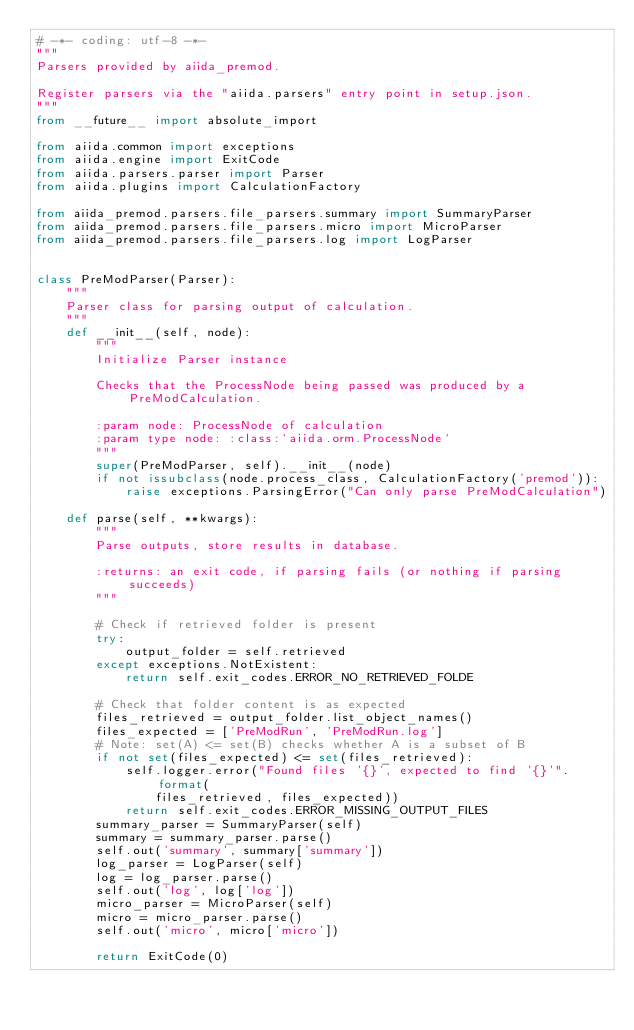Convert code to text. <code><loc_0><loc_0><loc_500><loc_500><_Python_># -*- coding: utf-8 -*-
"""
Parsers provided by aiida_premod.

Register parsers via the "aiida.parsers" entry point in setup.json.
"""
from __future__ import absolute_import

from aiida.common import exceptions
from aiida.engine import ExitCode
from aiida.parsers.parser import Parser
from aiida.plugins import CalculationFactory

from aiida_premod.parsers.file_parsers.summary import SummaryParser
from aiida_premod.parsers.file_parsers.micro import MicroParser
from aiida_premod.parsers.file_parsers.log import LogParser


class PreModParser(Parser):
    """
    Parser class for parsing output of calculation.
    """
    def __init__(self, node):
        """
        Initialize Parser instance

        Checks that the ProcessNode being passed was produced by a PreModCalculation.

        :param node: ProcessNode of calculation
        :param type node: :class:`aiida.orm.ProcessNode`
        """
        super(PreModParser, self).__init__(node)
        if not issubclass(node.process_class, CalculationFactory('premod')):
            raise exceptions.ParsingError("Can only parse PreModCalculation")

    def parse(self, **kwargs):
        """
        Parse outputs, store results in database.

        :returns: an exit code, if parsing fails (or nothing if parsing succeeds)
        """

        # Check if retrieved folder is present
        try:
            output_folder = self.retrieved
        except exceptions.NotExistent:
            return self.exit_codes.ERROR_NO_RETRIEVED_FOLDE

        # Check that folder content is as expected
        files_retrieved = output_folder.list_object_names()
        files_expected = ['PreModRun', 'PreModRun.log']
        # Note: set(A) <= set(B) checks whether A is a subset of B
        if not set(files_expected) <= set(files_retrieved):
            self.logger.error("Found files '{}', expected to find '{}'".format(
                files_retrieved, files_expected))
            return self.exit_codes.ERROR_MISSING_OUTPUT_FILES
        summary_parser = SummaryParser(self)
        summary = summary_parser.parse()
        self.out('summary', summary['summary'])
        log_parser = LogParser(self)
        log = log_parser.parse()
        self.out('log', log['log'])
        micro_parser = MicroParser(self)
        micro = micro_parser.parse()
        self.out('micro', micro['micro'])

        return ExitCode(0)
</code> 